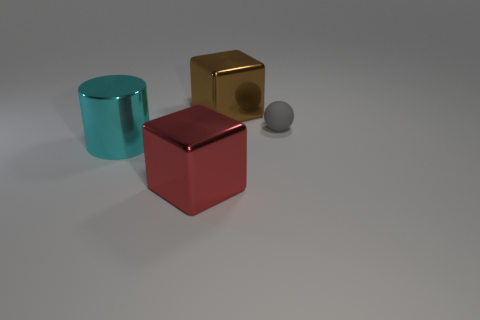Add 4 brown metallic cylinders. How many objects exist? 8 Subtract all spheres. How many objects are left? 3 Add 4 metal things. How many metal things exist? 7 Subtract 1 gray balls. How many objects are left? 3 Subtract all gray spheres. Subtract all cyan cylinders. How many objects are left? 2 Add 3 things. How many things are left? 7 